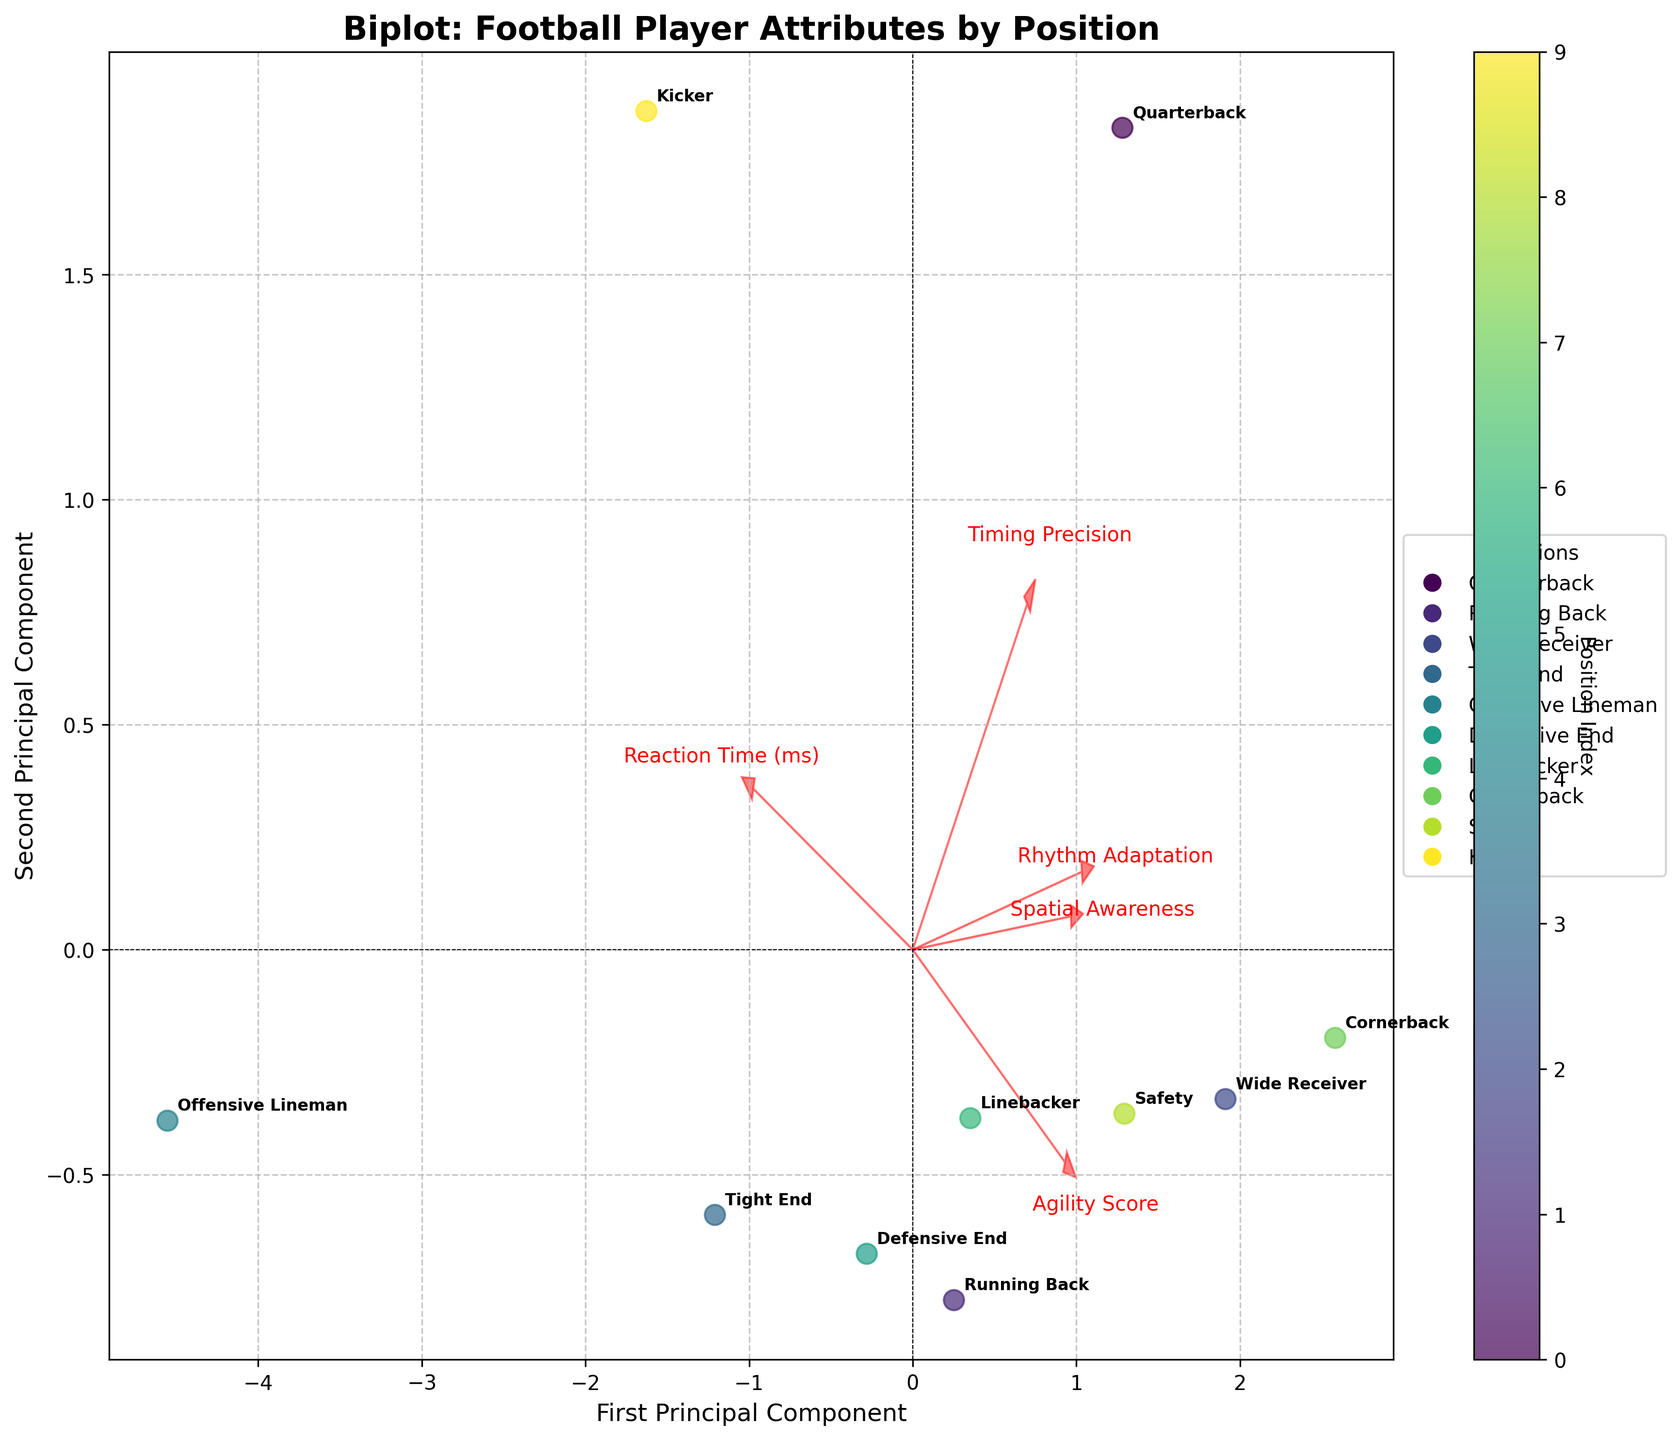What's the title of the figure? The title is written at the top of the figure in bold text.
Answer: Biplot: Football Player Attributes by Position Which position has the lowest reaction time? Reaction time is visually assessed based on the scatter plot's labels. Quarterback, Running Back, Wide Receiver, Cornerback, and Safety have different reaction times, with Cornerback appearing the lowest at around 182 ms.
Answer: Cornerback How are the 'Reaction Time' and 'Agility Score' features represented in the biplot? The features are represented as arrows starting from the origin, with their direction and length showing correlations with the principal components.
Answer: Arrows Which position has the highest agility score? Look for the position labels near the arrow representing agility. The 'Agility Score' might show up around 9.6 for Cornerback.
Answer: Cornerback What can be inferred about the relationship between 'Rhythm Adaptation' and 'Timing Precision'? By observing the directions of the arrows for these features, one can infer if they are closely aligned (indicating a strong correlation).
Answer: Positive correlation What position is near the origin of the plot? Check for the label closest to the (0, 0) point in the scatter plot. Kicker appears near the origin.
Answer: Kicker Which two positions appear closest together in the plot? How does it reflect their attributes? Visually identify the two positions that are nearest to each other. They share similar attributes, indicated by their close points. Linebacker and Defensive End are close together, reflecting shared attributes.
Answer: Linebacker and Defensive End Which position is most associated with 'Timing Precision'? Follow the arrow representing 'Timing Precision' to the scatter plot points. Quarterback shows high association due to its proximity.
Answer: Quarterback Explain the diversity in spatial awareness among football players. The scatter plot positions indicate the variance in 'Spatial Awareness' scores. Players are spread out differently along the arrow, showing varied spatial awareness levels.
Answer: Diverse What does the first principal component represent in the plot? The first principal component is usually along the x-axis, representing the most significant variance in the dataset, influenced by all visualized features.
Answer: Most significant variance Which feature has the weakest influence on the first principal component? The shortest arrow in the direction of the x-axis represents the weakest influence. 'Rhythm Adaptation' seems shortest.
Answer: Rhythm Adaptation 